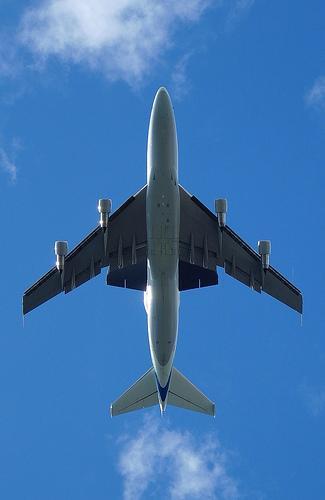How many planes are in the picture?
Give a very brief answer. 1. 